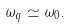Convert formula to latex. <formula><loc_0><loc_0><loc_500><loc_500>\omega _ { q } \simeq \omega _ { 0 } .</formula> 